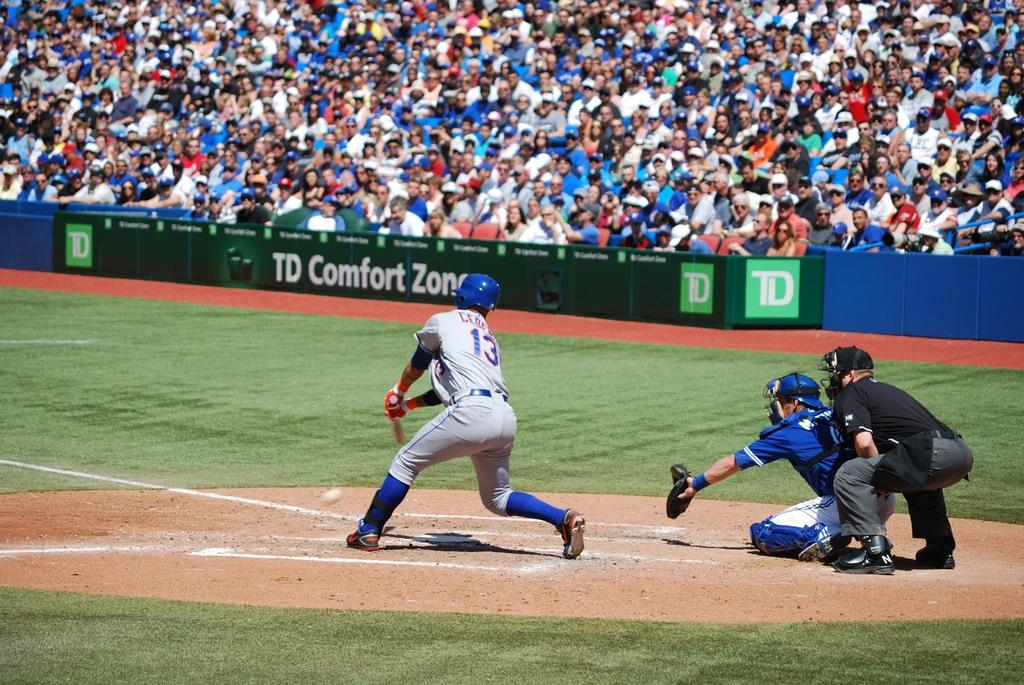<image>
Render a clear and concise summary of the photo. A TD Comfort Zone ad is near spectators watching a baseball game. 